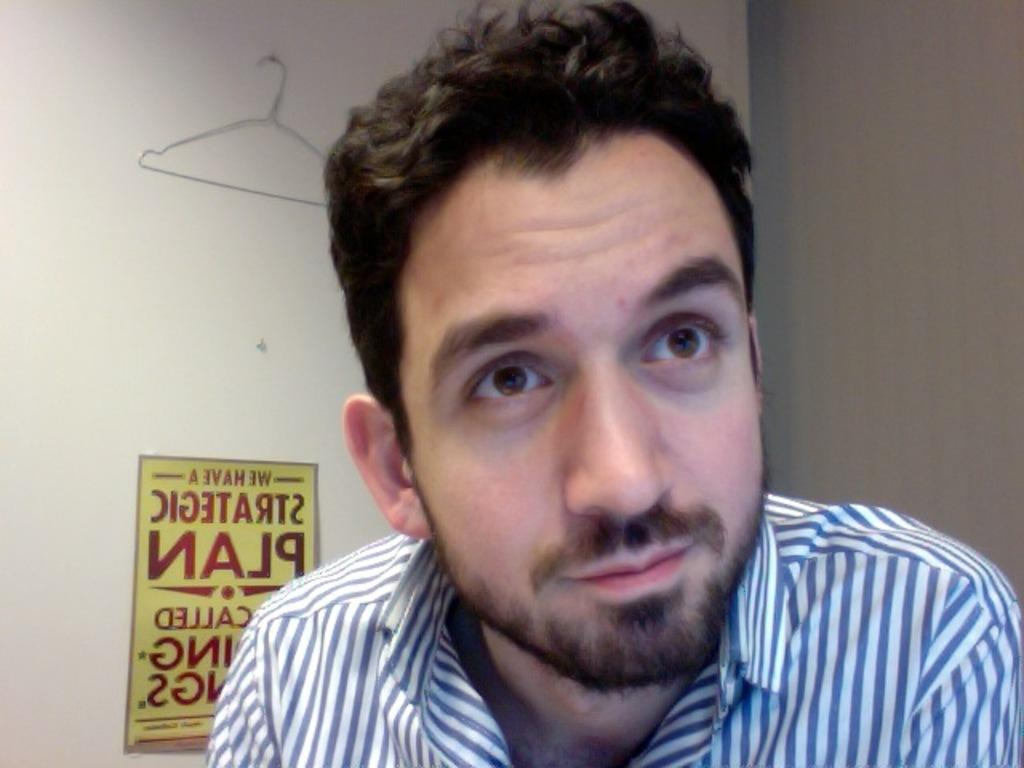Who is present in the image? There is a man in the image. What is the man wearing? The man is wearing a shirt with blue and white color lines. Can you describe the man's facial hair? The man has a beard. What can be seen in the background of the image? There is a door in the background of the image. What is attached to the door? There is a hanger attached to the door. What type of prison is depicted in the image? There is no prison present in the image; it features a man with a beard wearing a shirt with blue and white color lines. 